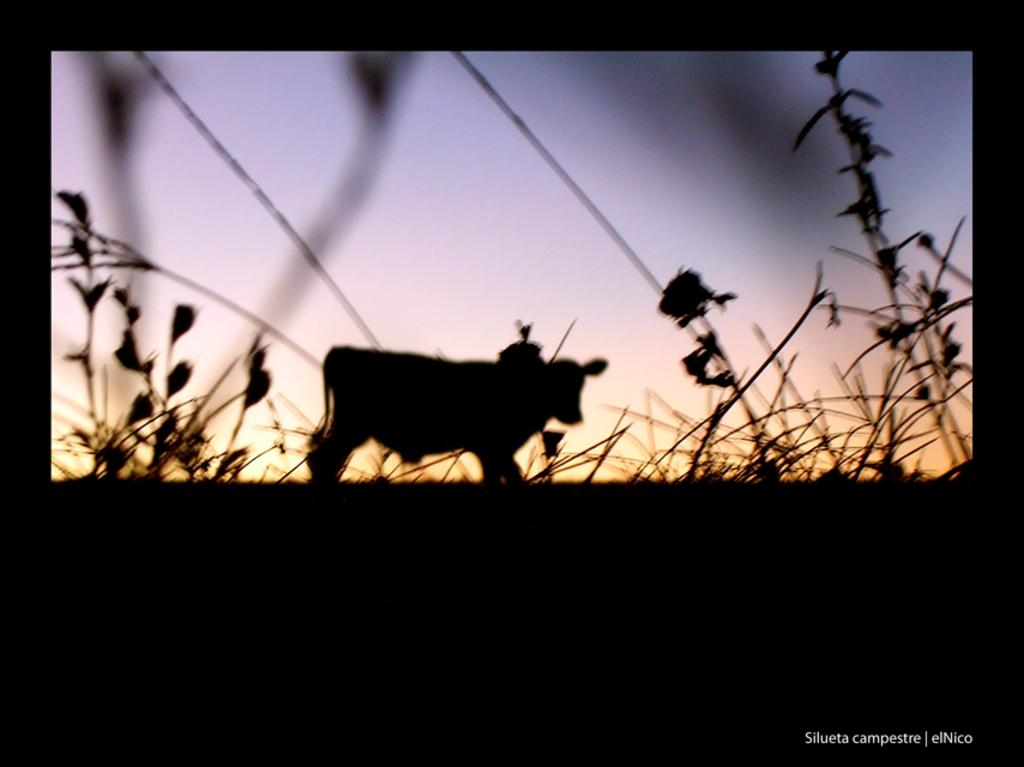What is the main feature in the foreground of the image? There is a black border in the foreground of the image. What can be seen on the plants in the image? There is a shade of a cow on the plants. What is visible in the background of the image? The sky is visible in the background of the image. What type of design can be seen on the zephyr in the image? There is no zephyr present in the image, so it is not possible to determine the design on it. 